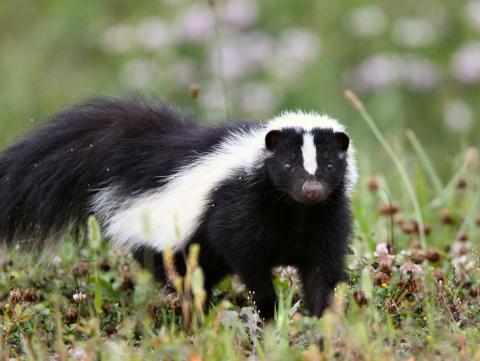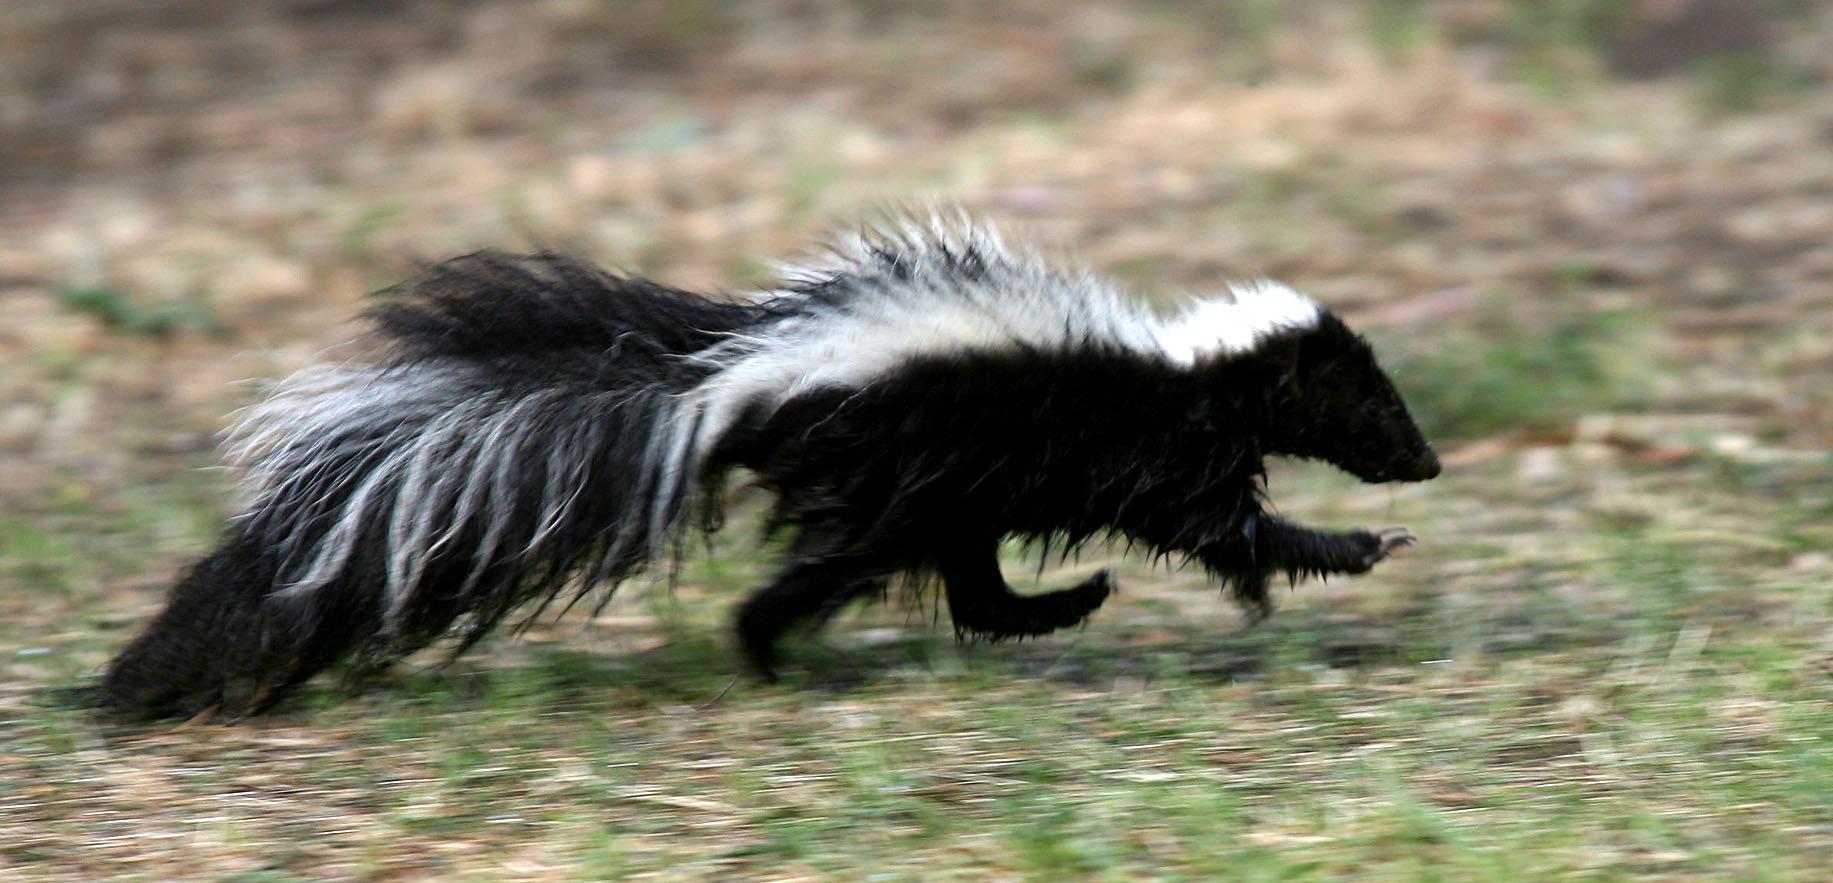The first image is the image on the left, the second image is the image on the right. Analyze the images presented: Is the assertion "The skunk on the left is standing still and looking forward, and the skunk on the right is trotting in a horizontal path." valid? Answer yes or no. Yes. The first image is the image on the left, the second image is the image on the right. For the images shown, is this caption "In at least one image there is a black and white skunk in the grass with its body facing left." true? Answer yes or no. No. 